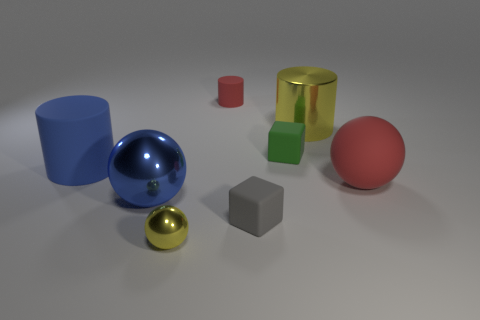Add 2 large green objects. How many objects exist? 10 Subtract all blocks. How many objects are left? 6 Add 5 green rubber cubes. How many green rubber cubes are left? 6 Add 8 small green rubber cubes. How many small green rubber cubes exist? 9 Subtract 1 blue spheres. How many objects are left? 7 Subtract all blue matte cylinders. Subtract all cubes. How many objects are left? 5 